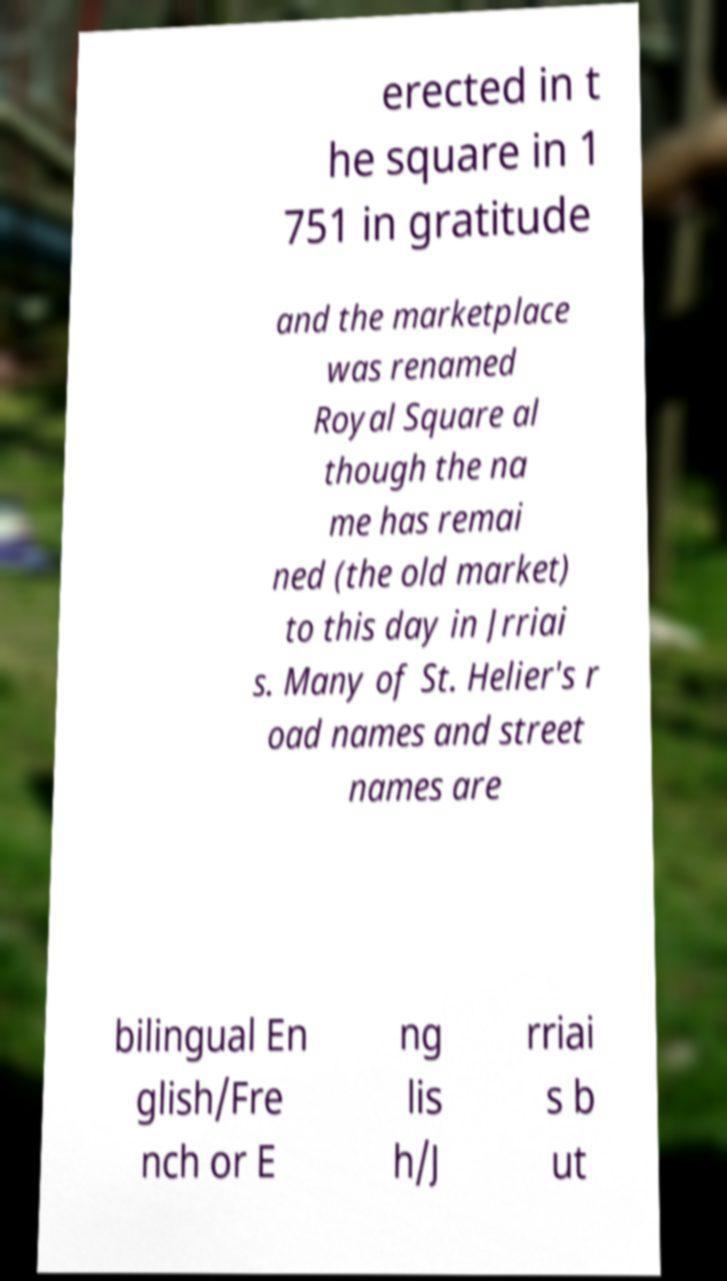Can you accurately transcribe the text from the provided image for me? erected in t he square in 1 751 in gratitude and the marketplace was renamed Royal Square al though the na me has remai ned (the old market) to this day in Jrriai s. Many of St. Helier's r oad names and street names are bilingual En glish/Fre nch or E ng lis h/J rriai s b ut 